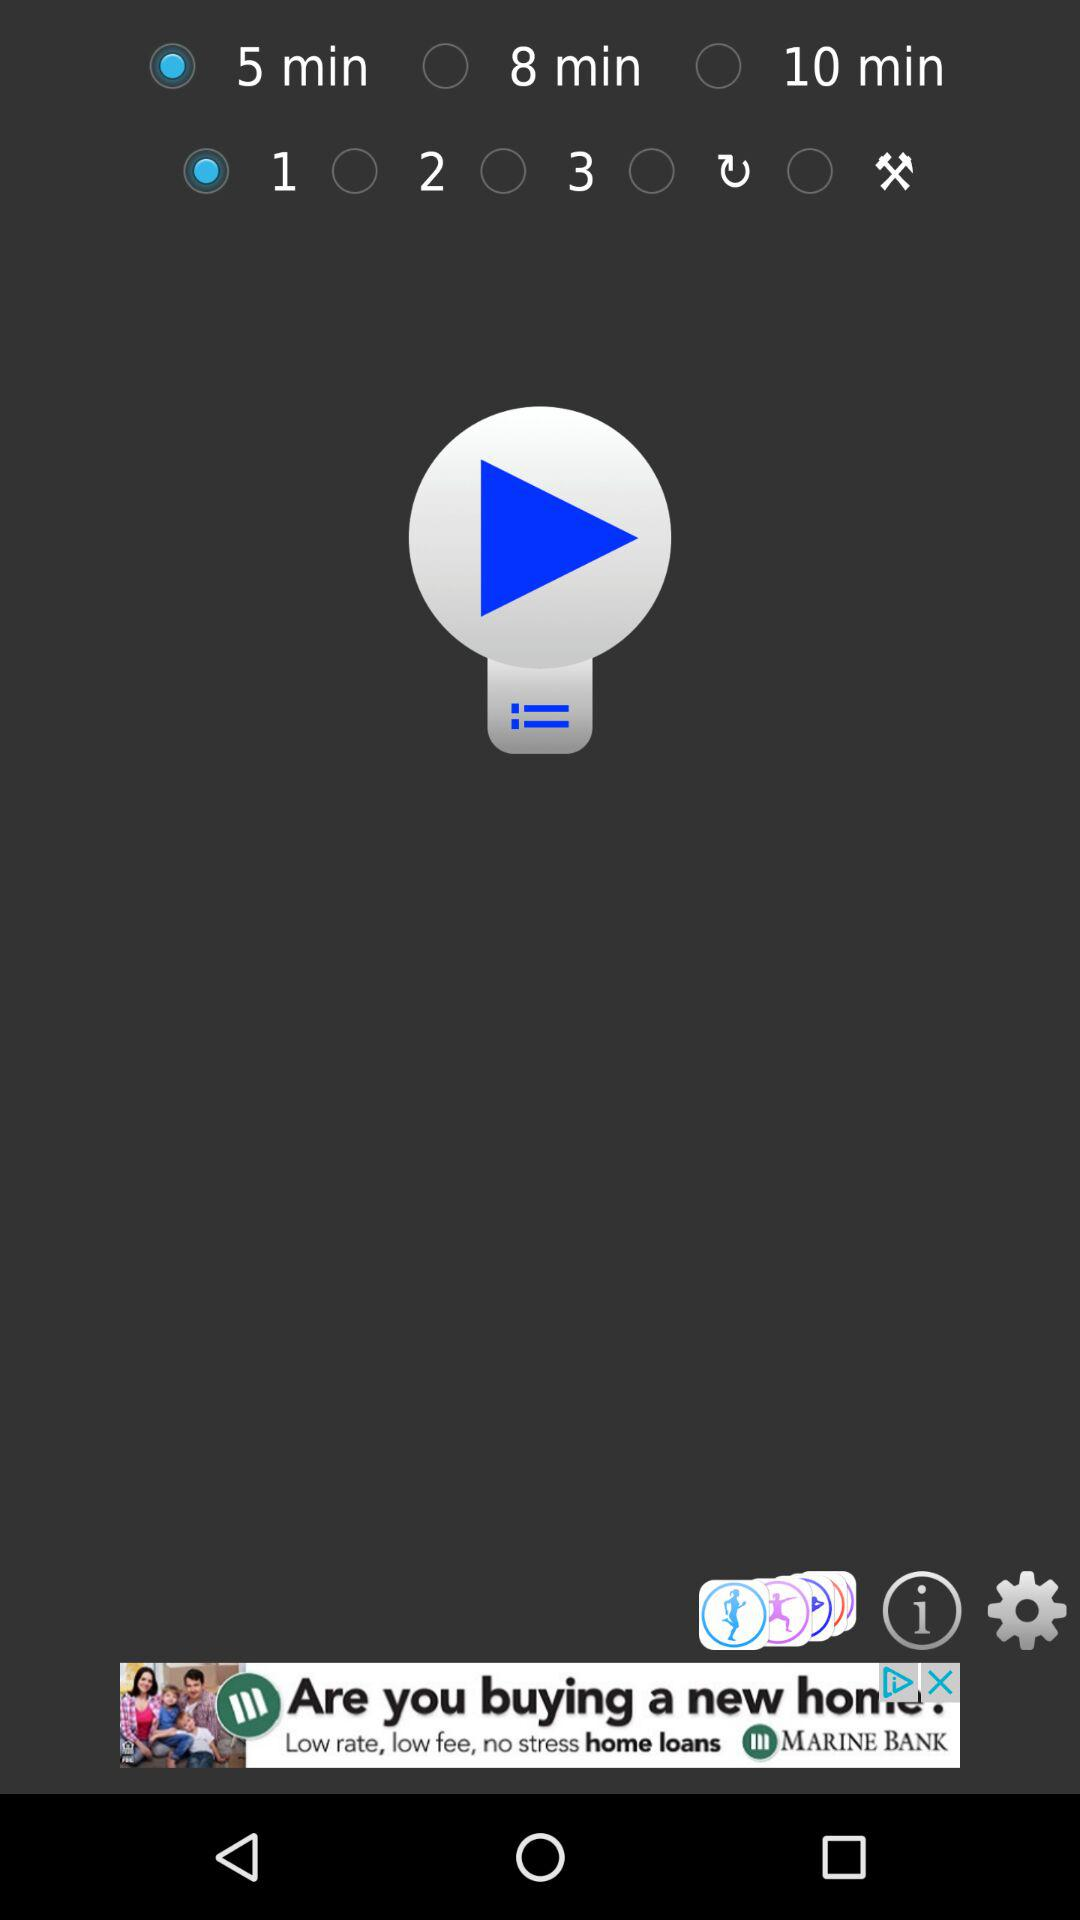How many more minutes are there in the 8 min option than the 5 min option?
Answer the question using a single word or phrase. 3 